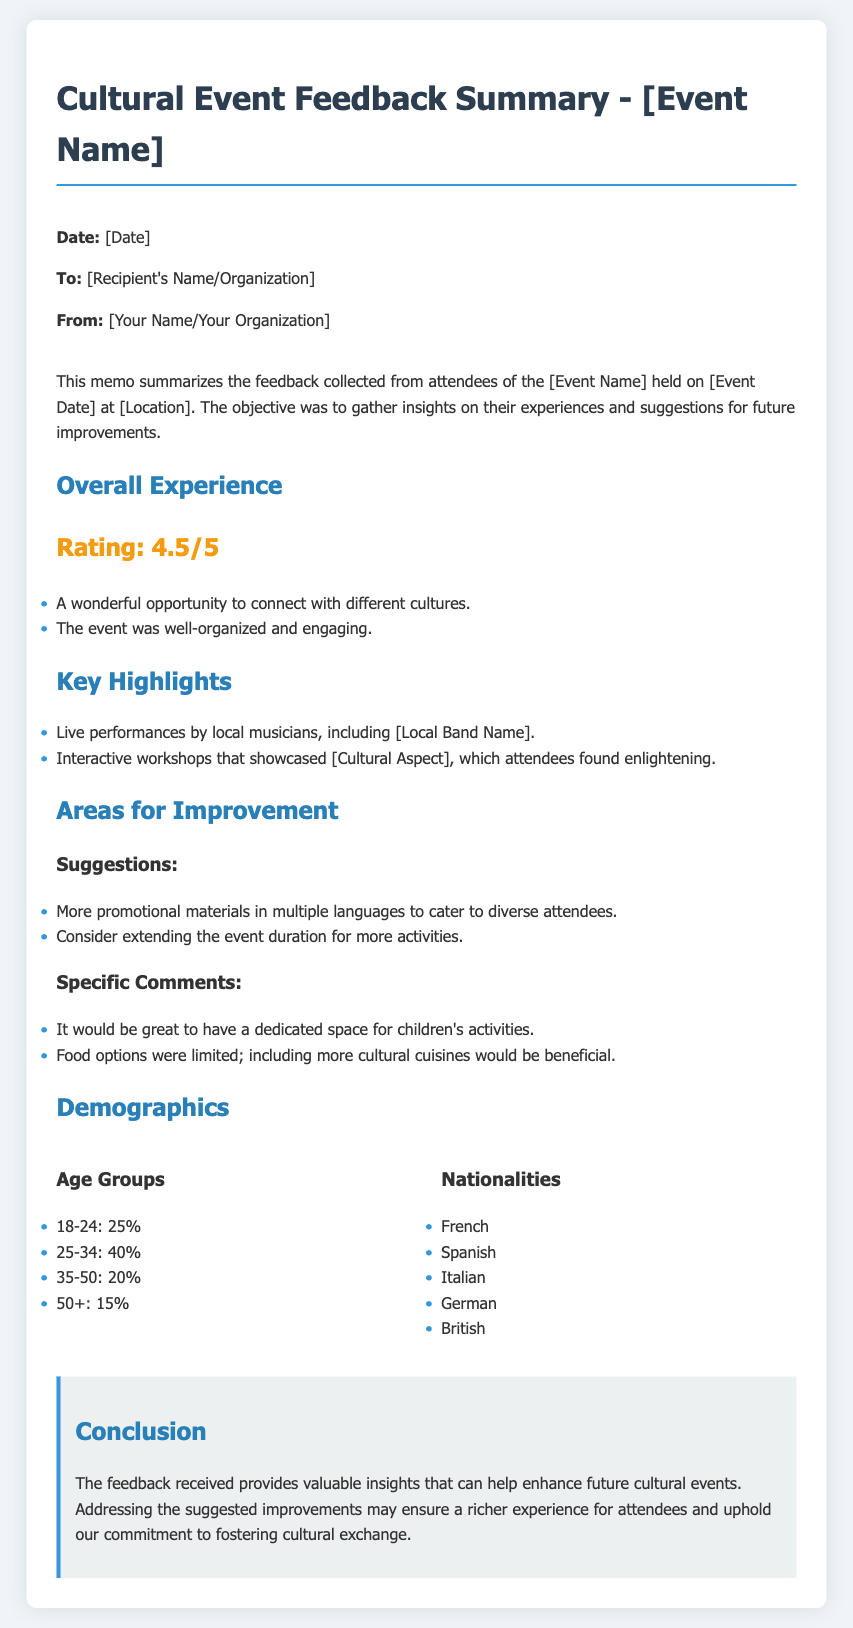What was the overall rating of the event? The overall rating is stated as 4.5 out of 5 in the document.
Answer: 4.5/5 What percentage of attendees were aged 25-34? The document specifies that 40% of attendees were in the 25-34 age group.
Answer: 40% What type of performances were highlighted? The document notes live performances by local musicians as a highlight.
Answer: Live performances What nationality is mentioned as one of the attendees? The document lists French as one of the attending nationalities.
Answer: French What suggestion was made regarding food options? The feedback indicates that including more cultural cuisines would be beneficial.
Answer: More cultural cuisines What was one of the specific comments made for improvement? The document mentions a suggestion for having a dedicated space for children's activities.
Answer: Dedicated space for children's activities What is the main objective of collecting feedback according to the memo? The objective outlined in the memo is to gather insights on attendees' experiences and suggestions for improvements.
Answer: Gather insights on experiences and suggestions What kind of promotional materials were suggested to cater to diverse attendees? The feedback suggests providing more promotional materials in multiple languages.
Answer: Promotional materials in multiple languages 